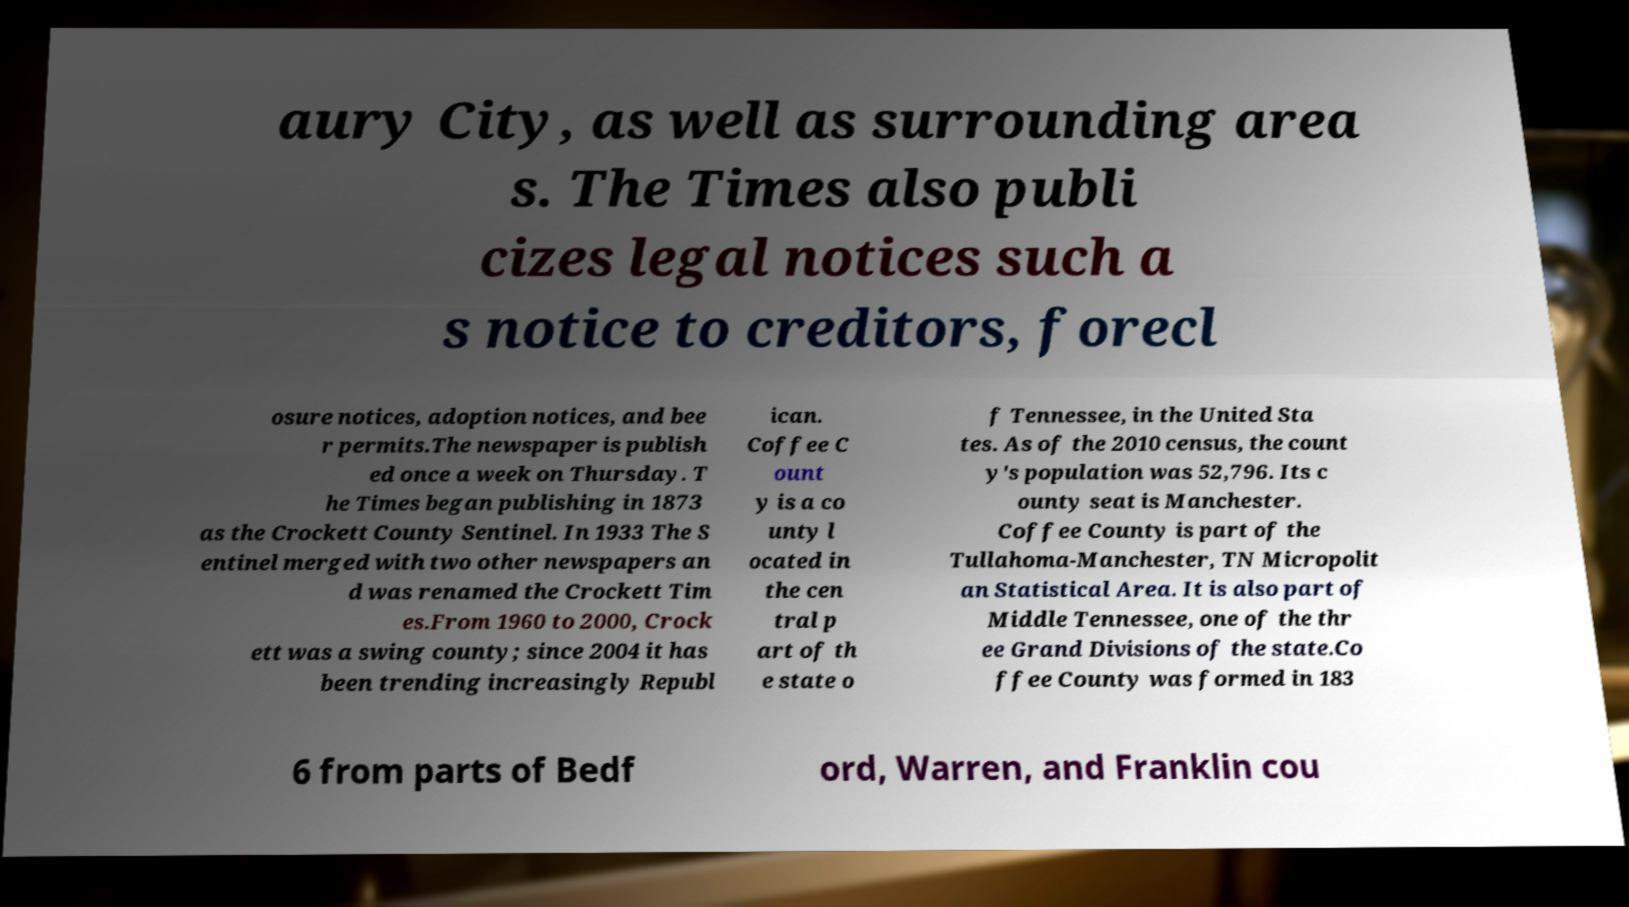For documentation purposes, I need the text within this image transcribed. Could you provide that? aury City, as well as surrounding area s. The Times also publi cizes legal notices such a s notice to creditors, forecl osure notices, adoption notices, and bee r permits.The newspaper is publish ed once a week on Thursday. T he Times began publishing in 1873 as the Crockett County Sentinel. In 1933 The S entinel merged with two other newspapers an d was renamed the Crockett Tim es.From 1960 to 2000, Crock ett was a swing county; since 2004 it has been trending increasingly Republ ican. Coffee C ount y is a co unty l ocated in the cen tral p art of th e state o f Tennessee, in the United Sta tes. As of the 2010 census, the count y's population was 52,796. Its c ounty seat is Manchester. Coffee County is part of the Tullahoma-Manchester, TN Micropolit an Statistical Area. It is also part of Middle Tennessee, one of the thr ee Grand Divisions of the state.Co ffee County was formed in 183 6 from parts of Bedf ord, Warren, and Franklin cou 